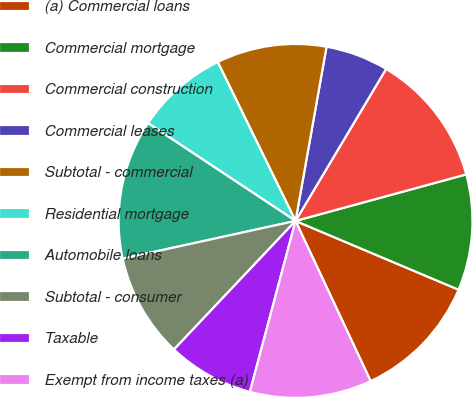<chart> <loc_0><loc_0><loc_500><loc_500><pie_chart><fcel>(a) Commercial loans<fcel>Commercial mortgage<fcel>Commercial construction<fcel>Commercial leases<fcel>Subtotal - commercial<fcel>Residential mortgage<fcel>Automobile loans<fcel>Subtotal - consumer<fcel>Taxable<fcel>Exempt from income taxes (a)<nl><fcel>11.67%<fcel>10.59%<fcel>12.21%<fcel>5.75%<fcel>10.05%<fcel>8.44%<fcel>12.74%<fcel>9.52%<fcel>7.9%<fcel>11.13%<nl></chart> 